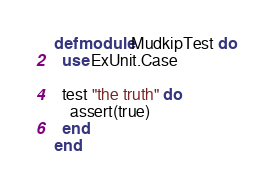<code> <loc_0><loc_0><loc_500><loc_500><_Elixir_>defmodule MudkipTest do
  use ExUnit.Case

  test "the truth" do
    assert(true)
  end
end
</code> 